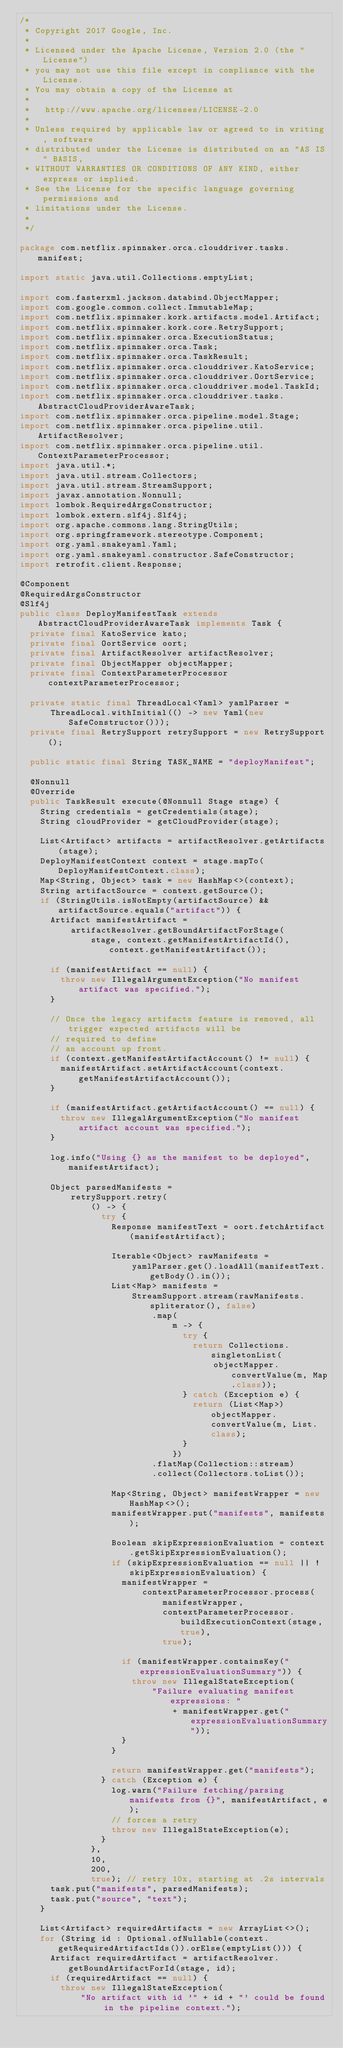Convert code to text. <code><loc_0><loc_0><loc_500><loc_500><_Java_>/*
 * Copyright 2017 Google, Inc.
 *
 * Licensed under the Apache License, Version 2.0 (the "License")
 * you may not use this file except in compliance with the License.
 * You may obtain a copy of the License at
 *
 *   http://www.apache.org/licenses/LICENSE-2.0
 *
 * Unless required by applicable law or agreed to in writing, software
 * distributed under the License is distributed on an "AS IS" BASIS,
 * WITHOUT WARRANTIES OR CONDITIONS OF ANY KIND, either express or implied.
 * See the License for the specific language governing permissions and
 * limitations under the License.
 *
 */

package com.netflix.spinnaker.orca.clouddriver.tasks.manifest;

import static java.util.Collections.emptyList;

import com.fasterxml.jackson.databind.ObjectMapper;
import com.google.common.collect.ImmutableMap;
import com.netflix.spinnaker.kork.artifacts.model.Artifact;
import com.netflix.spinnaker.kork.core.RetrySupport;
import com.netflix.spinnaker.orca.ExecutionStatus;
import com.netflix.spinnaker.orca.Task;
import com.netflix.spinnaker.orca.TaskResult;
import com.netflix.spinnaker.orca.clouddriver.KatoService;
import com.netflix.spinnaker.orca.clouddriver.OortService;
import com.netflix.spinnaker.orca.clouddriver.model.TaskId;
import com.netflix.spinnaker.orca.clouddriver.tasks.AbstractCloudProviderAwareTask;
import com.netflix.spinnaker.orca.pipeline.model.Stage;
import com.netflix.spinnaker.orca.pipeline.util.ArtifactResolver;
import com.netflix.spinnaker.orca.pipeline.util.ContextParameterProcessor;
import java.util.*;
import java.util.stream.Collectors;
import java.util.stream.StreamSupport;
import javax.annotation.Nonnull;
import lombok.RequiredArgsConstructor;
import lombok.extern.slf4j.Slf4j;
import org.apache.commons.lang.StringUtils;
import org.springframework.stereotype.Component;
import org.yaml.snakeyaml.Yaml;
import org.yaml.snakeyaml.constructor.SafeConstructor;
import retrofit.client.Response;

@Component
@RequiredArgsConstructor
@Slf4j
public class DeployManifestTask extends AbstractCloudProviderAwareTask implements Task {
  private final KatoService kato;
  private final OortService oort;
  private final ArtifactResolver artifactResolver;
  private final ObjectMapper objectMapper;
  private final ContextParameterProcessor contextParameterProcessor;

  private static final ThreadLocal<Yaml> yamlParser =
      ThreadLocal.withInitial(() -> new Yaml(new SafeConstructor()));
  private final RetrySupport retrySupport = new RetrySupport();

  public static final String TASK_NAME = "deployManifest";

  @Nonnull
  @Override
  public TaskResult execute(@Nonnull Stage stage) {
    String credentials = getCredentials(stage);
    String cloudProvider = getCloudProvider(stage);

    List<Artifact> artifacts = artifactResolver.getArtifacts(stage);
    DeployManifestContext context = stage.mapTo(DeployManifestContext.class);
    Map<String, Object> task = new HashMap<>(context);
    String artifactSource = context.getSource();
    if (StringUtils.isNotEmpty(artifactSource) && artifactSource.equals("artifact")) {
      Artifact manifestArtifact =
          artifactResolver.getBoundArtifactForStage(
              stage, context.getManifestArtifactId(), context.getManifestArtifact());

      if (manifestArtifact == null) {
        throw new IllegalArgumentException("No manifest artifact was specified.");
      }

      // Once the legacy artifacts feature is removed, all trigger expected artifacts will be
      // required to define
      // an account up front.
      if (context.getManifestArtifactAccount() != null) {
        manifestArtifact.setArtifactAccount(context.getManifestArtifactAccount());
      }

      if (manifestArtifact.getArtifactAccount() == null) {
        throw new IllegalArgumentException("No manifest artifact account was specified.");
      }

      log.info("Using {} as the manifest to be deployed", manifestArtifact);

      Object parsedManifests =
          retrySupport.retry(
              () -> {
                try {
                  Response manifestText = oort.fetchArtifact(manifestArtifact);

                  Iterable<Object> rawManifests =
                      yamlParser.get().loadAll(manifestText.getBody().in());
                  List<Map> manifests =
                      StreamSupport.stream(rawManifests.spliterator(), false)
                          .map(
                              m -> {
                                try {
                                  return Collections.singletonList(
                                      objectMapper.convertValue(m, Map.class));
                                } catch (Exception e) {
                                  return (List<Map>) objectMapper.convertValue(m, List.class);
                                }
                              })
                          .flatMap(Collection::stream)
                          .collect(Collectors.toList());

                  Map<String, Object> manifestWrapper = new HashMap<>();
                  manifestWrapper.put("manifests", manifests);

                  Boolean skipExpressionEvaluation = context.getSkipExpressionEvaluation();
                  if (skipExpressionEvaluation == null || !skipExpressionEvaluation) {
                    manifestWrapper =
                        contextParameterProcessor.process(
                            manifestWrapper,
                            contextParameterProcessor.buildExecutionContext(stage, true),
                            true);

                    if (manifestWrapper.containsKey("expressionEvaluationSummary")) {
                      throw new IllegalStateException(
                          "Failure evaluating manifest expressions: "
                              + manifestWrapper.get("expressionEvaluationSummary"));
                    }
                  }

                  return manifestWrapper.get("manifests");
                } catch (Exception e) {
                  log.warn("Failure fetching/parsing manifests from {}", manifestArtifact, e);
                  // forces a retry
                  throw new IllegalStateException(e);
                }
              },
              10,
              200,
              true); // retry 10x, starting at .2s intervals
      task.put("manifests", parsedManifests);
      task.put("source", "text");
    }

    List<Artifact> requiredArtifacts = new ArrayList<>();
    for (String id : Optional.ofNullable(context.getRequiredArtifactIds()).orElse(emptyList())) {
      Artifact requiredArtifact = artifactResolver.getBoundArtifactForId(stage, id);
      if (requiredArtifact == null) {
        throw new IllegalStateException(
            "No artifact with id '" + id + "' could be found in the pipeline context.");</code> 